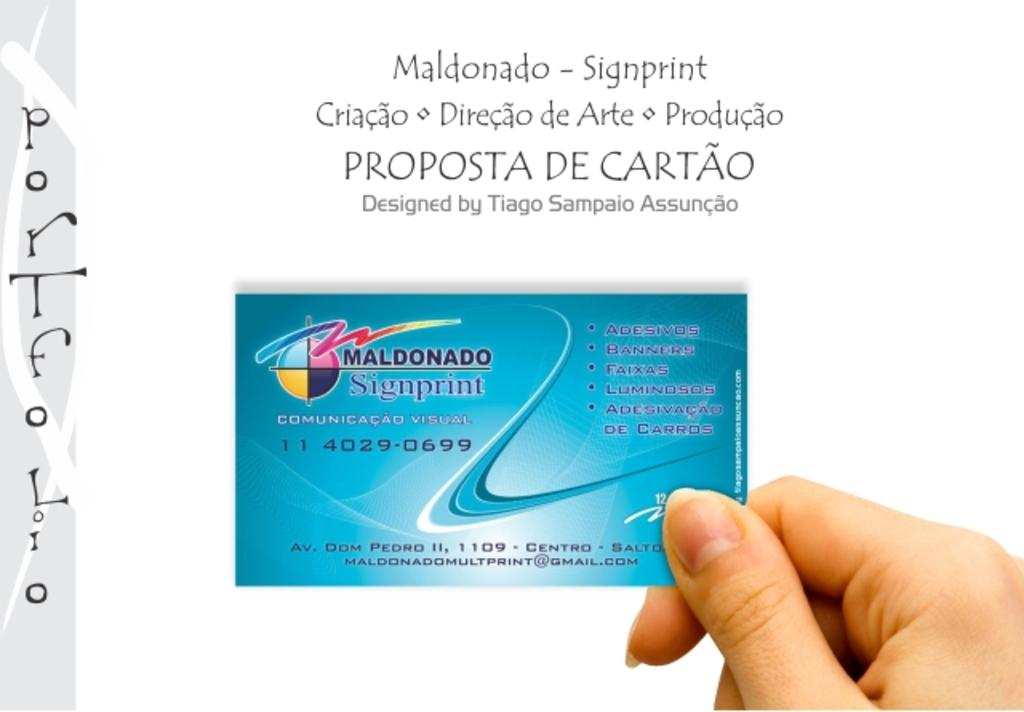What is the main subject of the image? There is a person in the image. What is the person holding in the image? The person is holding a card. Can you describe any text visible in the image? Yes, there is text visible in the image. How many boys are on the boat in the image? There is no boat or boys present in the image. What type of twist is the person performing with the card in the image? There is no indication of a twist or any specific action with the card in the image. 